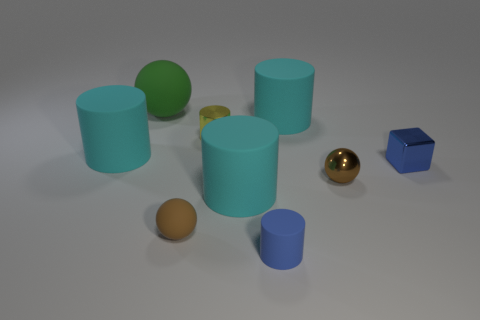What color is the tiny thing that is made of the same material as the blue cylinder?
Make the answer very short. Brown. What is the color of the tiny thing that is in front of the brown matte thing?
Your answer should be compact. Blue. How many small rubber balls have the same color as the large rubber ball?
Provide a succinct answer. 0. Are there fewer small brown rubber spheres that are left of the large matte sphere than brown spheres in front of the yellow cylinder?
Offer a terse response. Yes. There is a yellow cylinder; what number of brown objects are to the right of it?
Provide a succinct answer. 1. Are there any big yellow blocks made of the same material as the green object?
Provide a succinct answer. No. Are there more yellow objects to the left of the tiny yellow metallic cylinder than cylinders on the left side of the small brown matte ball?
Provide a short and direct response. No. How big is the yellow metallic cylinder?
Ensure brevity in your answer.  Small. What shape is the brown object left of the blue matte cylinder?
Your response must be concise. Sphere. Is the big green thing the same shape as the small brown matte object?
Provide a short and direct response. Yes. 